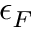Convert formula to latex. <formula><loc_0><loc_0><loc_500><loc_500>\epsilon _ { F }</formula> 